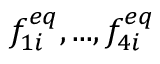<formula> <loc_0><loc_0><loc_500><loc_500>f _ { 1 i } ^ { e q } , \dots , f _ { 4 i } ^ { e q }</formula> 